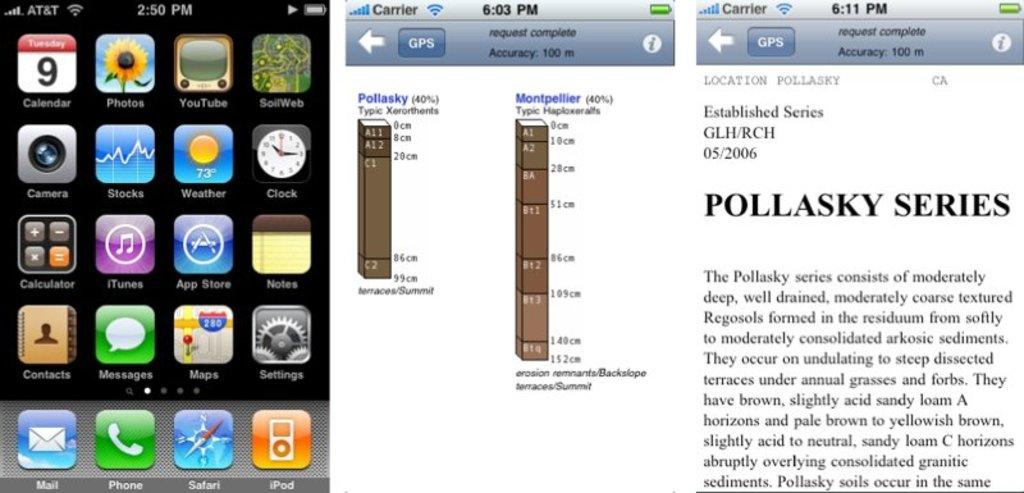<image>
Create a compact narrative representing the image presented. Three phone screen shots include two that have a GPS button at the top. 